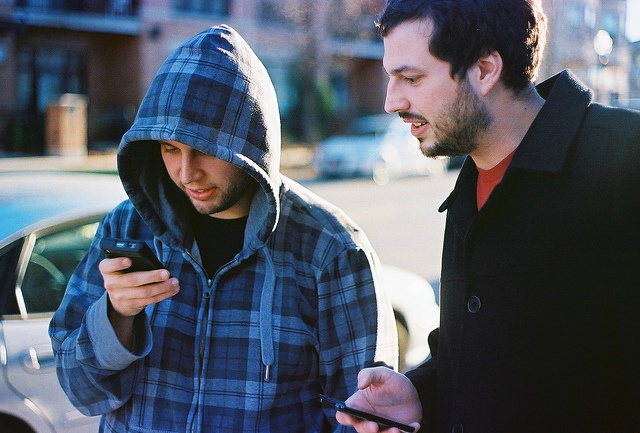Describe the objects in this image and their specific colors. I can see people in blue, black, navy, and darkblue tones, people in blue, black, gray, and lightpink tones, car in blue, white, darkgray, black, and teal tones, car in blue, lightgray, lightblue, and gray tones, and cell phone in blue, black, and navy tones in this image. 